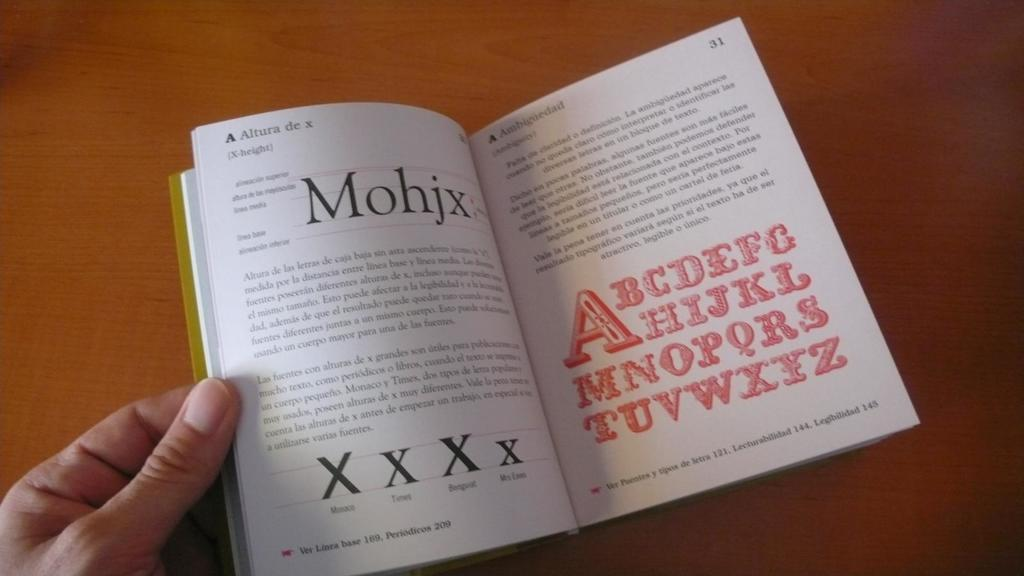<image>
Write a terse but informative summary of the picture. A book is open to page 31, which has the English alphabet written in red. 